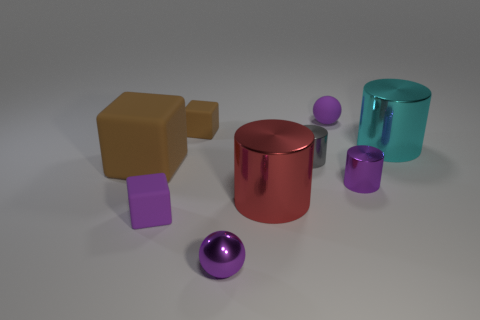Are there any large red metal cylinders on the right side of the purple rubber ball? no 